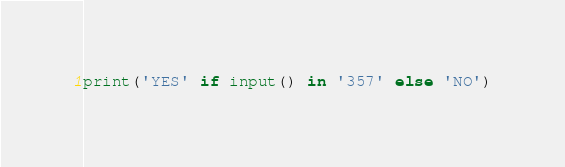<code> <loc_0><loc_0><loc_500><loc_500><_Python_>print('YES' if input() in '357' else 'NO')</code> 